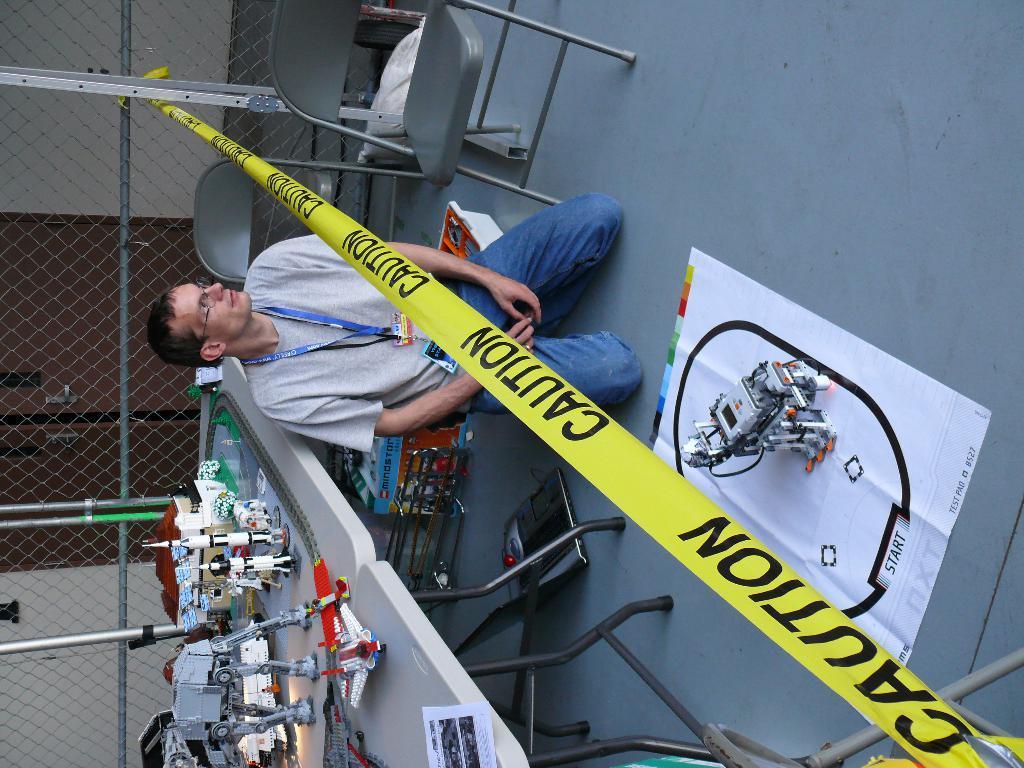Could you give a brief overview of what you see in this image? This image is taken indoors. On the right side of the image there is a floor and there is a robot on the floor. On the left side of the image there is a mesh with a few iron bars. At the bottom of the image there are two tables with a few things on them. In the middle of the image there are two empty chairs and a man is sitting on the floor and there is a caution ribbon. 